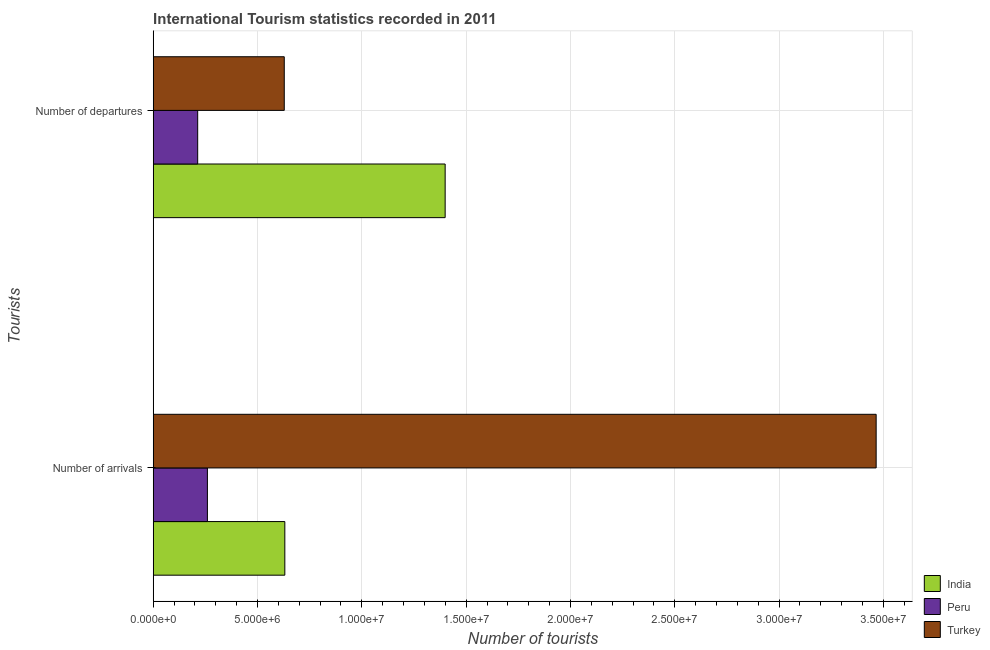How many different coloured bars are there?
Keep it short and to the point. 3. Are the number of bars per tick equal to the number of legend labels?
Provide a succinct answer. Yes. How many bars are there on the 2nd tick from the top?
Make the answer very short. 3. What is the label of the 1st group of bars from the top?
Your answer should be compact. Number of departures. What is the number of tourist departures in India?
Offer a very short reply. 1.40e+07. Across all countries, what is the maximum number of tourist arrivals?
Your response must be concise. 3.47e+07. Across all countries, what is the minimum number of tourist arrivals?
Your response must be concise. 2.60e+06. In which country was the number of tourist arrivals maximum?
Your response must be concise. Turkey. What is the total number of tourist departures in the graph?
Offer a very short reply. 2.24e+07. What is the difference between the number of tourist arrivals in Peru and that in Turkey?
Your answer should be very brief. -3.21e+07. What is the difference between the number of tourist departures in India and the number of tourist arrivals in Peru?
Offer a very short reply. 1.14e+07. What is the average number of tourist arrivals per country?
Provide a short and direct response. 1.45e+07. What is the difference between the number of tourist arrivals and number of tourist departures in Turkey?
Make the answer very short. 2.84e+07. In how many countries, is the number of tourist departures greater than 21000000 ?
Provide a short and direct response. 0. What is the ratio of the number of tourist arrivals in Peru to that in Turkey?
Your answer should be compact. 0.07. Is the number of tourist departures in Peru less than that in Turkey?
Provide a short and direct response. Yes. What does the 3rd bar from the top in Number of departures represents?
Make the answer very short. India. What does the 2nd bar from the bottom in Number of arrivals represents?
Offer a very short reply. Peru. How many bars are there?
Give a very brief answer. 6. Are the values on the major ticks of X-axis written in scientific E-notation?
Offer a very short reply. Yes. Does the graph contain any zero values?
Provide a short and direct response. No. Does the graph contain grids?
Offer a very short reply. Yes. Where does the legend appear in the graph?
Your response must be concise. Bottom right. How many legend labels are there?
Provide a succinct answer. 3. What is the title of the graph?
Your answer should be very brief. International Tourism statistics recorded in 2011. What is the label or title of the X-axis?
Give a very brief answer. Number of tourists. What is the label or title of the Y-axis?
Keep it short and to the point. Tourists. What is the Number of tourists in India in Number of arrivals?
Keep it short and to the point. 6.31e+06. What is the Number of tourists in Peru in Number of arrivals?
Ensure brevity in your answer.  2.60e+06. What is the Number of tourists in Turkey in Number of arrivals?
Provide a succinct answer. 3.47e+07. What is the Number of tourists in India in Number of departures?
Your answer should be compact. 1.40e+07. What is the Number of tourists in Peru in Number of departures?
Offer a very short reply. 2.13e+06. What is the Number of tourists of Turkey in Number of departures?
Your answer should be compact. 6.28e+06. Across all Tourists, what is the maximum Number of tourists in India?
Make the answer very short. 1.40e+07. Across all Tourists, what is the maximum Number of tourists in Peru?
Provide a short and direct response. 2.60e+06. Across all Tourists, what is the maximum Number of tourists of Turkey?
Your answer should be very brief. 3.47e+07. Across all Tourists, what is the minimum Number of tourists of India?
Your answer should be very brief. 6.31e+06. Across all Tourists, what is the minimum Number of tourists of Peru?
Give a very brief answer. 2.13e+06. Across all Tourists, what is the minimum Number of tourists in Turkey?
Offer a terse response. 6.28e+06. What is the total Number of tourists in India in the graph?
Give a very brief answer. 2.03e+07. What is the total Number of tourists in Peru in the graph?
Make the answer very short. 4.73e+06. What is the total Number of tourists in Turkey in the graph?
Provide a succinct answer. 4.09e+07. What is the difference between the Number of tourists in India in Number of arrivals and that in Number of departures?
Provide a succinct answer. -7.68e+06. What is the difference between the Number of tourists of Peru in Number of arrivals and that in Number of departures?
Provide a succinct answer. 4.66e+05. What is the difference between the Number of tourists of Turkey in Number of arrivals and that in Number of departures?
Your answer should be compact. 2.84e+07. What is the difference between the Number of tourists in India in Number of arrivals and the Number of tourists in Peru in Number of departures?
Provide a short and direct response. 4.18e+06. What is the difference between the Number of tourists of India in Number of arrivals and the Number of tourists of Turkey in Number of departures?
Your response must be concise. 2.70e+04. What is the difference between the Number of tourists in Peru in Number of arrivals and the Number of tourists in Turkey in Number of departures?
Your response must be concise. -3.68e+06. What is the average Number of tourists in India per Tourists?
Give a very brief answer. 1.02e+07. What is the average Number of tourists in Peru per Tourists?
Your answer should be very brief. 2.36e+06. What is the average Number of tourists in Turkey per Tourists?
Provide a succinct answer. 2.05e+07. What is the difference between the Number of tourists in India and Number of tourists in Peru in Number of arrivals?
Give a very brief answer. 3.71e+06. What is the difference between the Number of tourists in India and Number of tourists in Turkey in Number of arrivals?
Provide a succinct answer. -2.83e+07. What is the difference between the Number of tourists of Peru and Number of tourists of Turkey in Number of arrivals?
Your answer should be compact. -3.21e+07. What is the difference between the Number of tourists of India and Number of tourists of Peru in Number of departures?
Keep it short and to the point. 1.19e+07. What is the difference between the Number of tourists in India and Number of tourists in Turkey in Number of departures?
Your answer should be compact. 7.71e+06. What is the difference between the Number of tourists of Peru and Number of tourists of Turkey in Number of departures?
Provide a succinct answer. -4.15e+06. What is the ratio of the Number of tourists of India in Number of arrivals to that in Number of departures?
Your response must be concise. 0.45. What is the ratio of the Number of tourists in Peru in Number of arrivals to that in Number of departures?
Keep it short and to the point. 1.22. What is the ratio of the Number of tourists of Turkey in Number of arrivals to that in Number of departures?
Provide a succinct answer. 5.52. What is the difference between the highest and the second highest Number of tourists in India?
Make the answer very short. 7.68e+06. What is the difference between the highest and the second highest Number of tourists in Peru?
Give a very brief answer. 4.66e+05. What is the difference between the highest and the second highest Number of tourists in Turkey?
Keep it short and to the point. 2.84e+07. What is the difference between the highest and the lowest Number of tourists in India?
Give a very brief answer. 7.68e+06. What is the difference between the highest and the lowest Number of tourists in Peru?
Give a very brief answer. 4.66e+05. What is the difference between the highest and the lowest Number of tourists of Turkey?
Provide a short and direct response. 2.84e+07. 